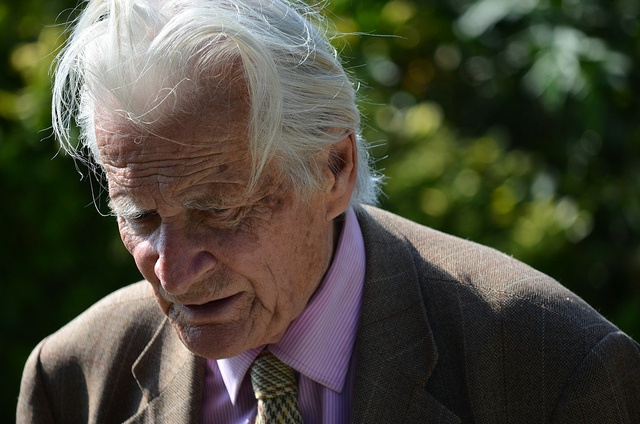Describe the objects in this image and their specific colors. I can see people in darkgreen, black, gray, maroon, and darkgray tones and tie in darkgreen, black, gray, and darkgray tones in this image. 